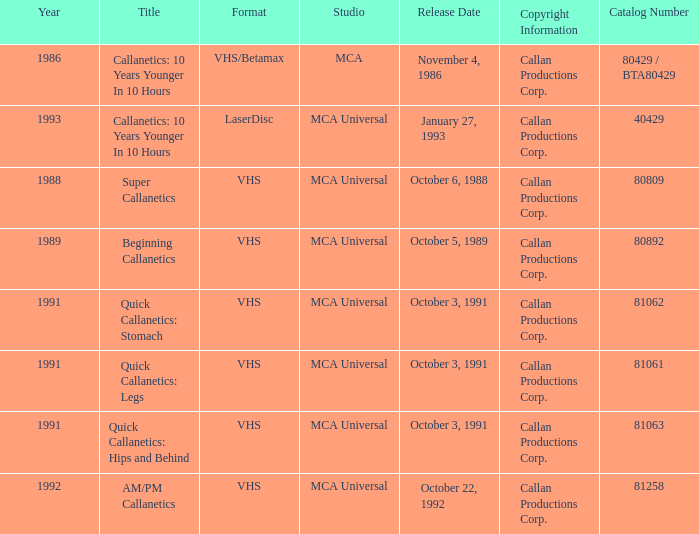Name the catalog number for  october 6, 1988 80809.0. Would you mind parsing the complete table? {'header': ['Year', 'Title', 'Format', 'Studio', 'Release Date', 'Copyright Information', 'Catalog Number'], 'rows': [['1986', 'Callanetics: 10 Years Younger In 10 Hours', 'VHS/Betamax', 'MCA', 'November 4, 1986', 'Callan Productions Corp.', '80429 / BTA80429'], ['1993', 'Callanetics: 10 Years Younger In 10 Hours', 'LaserDisc', 'MCA Universal', 'January 27, 1993', 'Callan Productions Corp.', '40429'], ['1988', 'Super Callanetics', 'VHS', 'MCA Universal', 'October 6, 1988', 'Callan Productions Corp.', '80809'], ['1989', 'Beginning Callanetics', 'VHS', 'MCA Universal', 'October 5, 1989', 'Callan Productions Corp.', '80892'], ['1991', 'Quick Callanetics: Stomach', 'VHS', 'MCA Universal', 'October 3, 1991', 'Callan Productions Corp.', '81062'], ['1991', 'Quick Callanetics: Legs', 'VHS', 'MCA Universal', 'October 3, 1991', 'Callan Productions Corp.', '81061'], ['1991', 'Quick Callanetics: Hips and Behind', 'VHS', 'MCA Universal', 'October 3, 1991', 'Callan Productions Corp.', '81063'], ['1992', 'AM/PM Callanetics', 'VHS', 'MCA Universal', 'October 22, 1992', 'Callan Productions Corp.', '81258']]} 